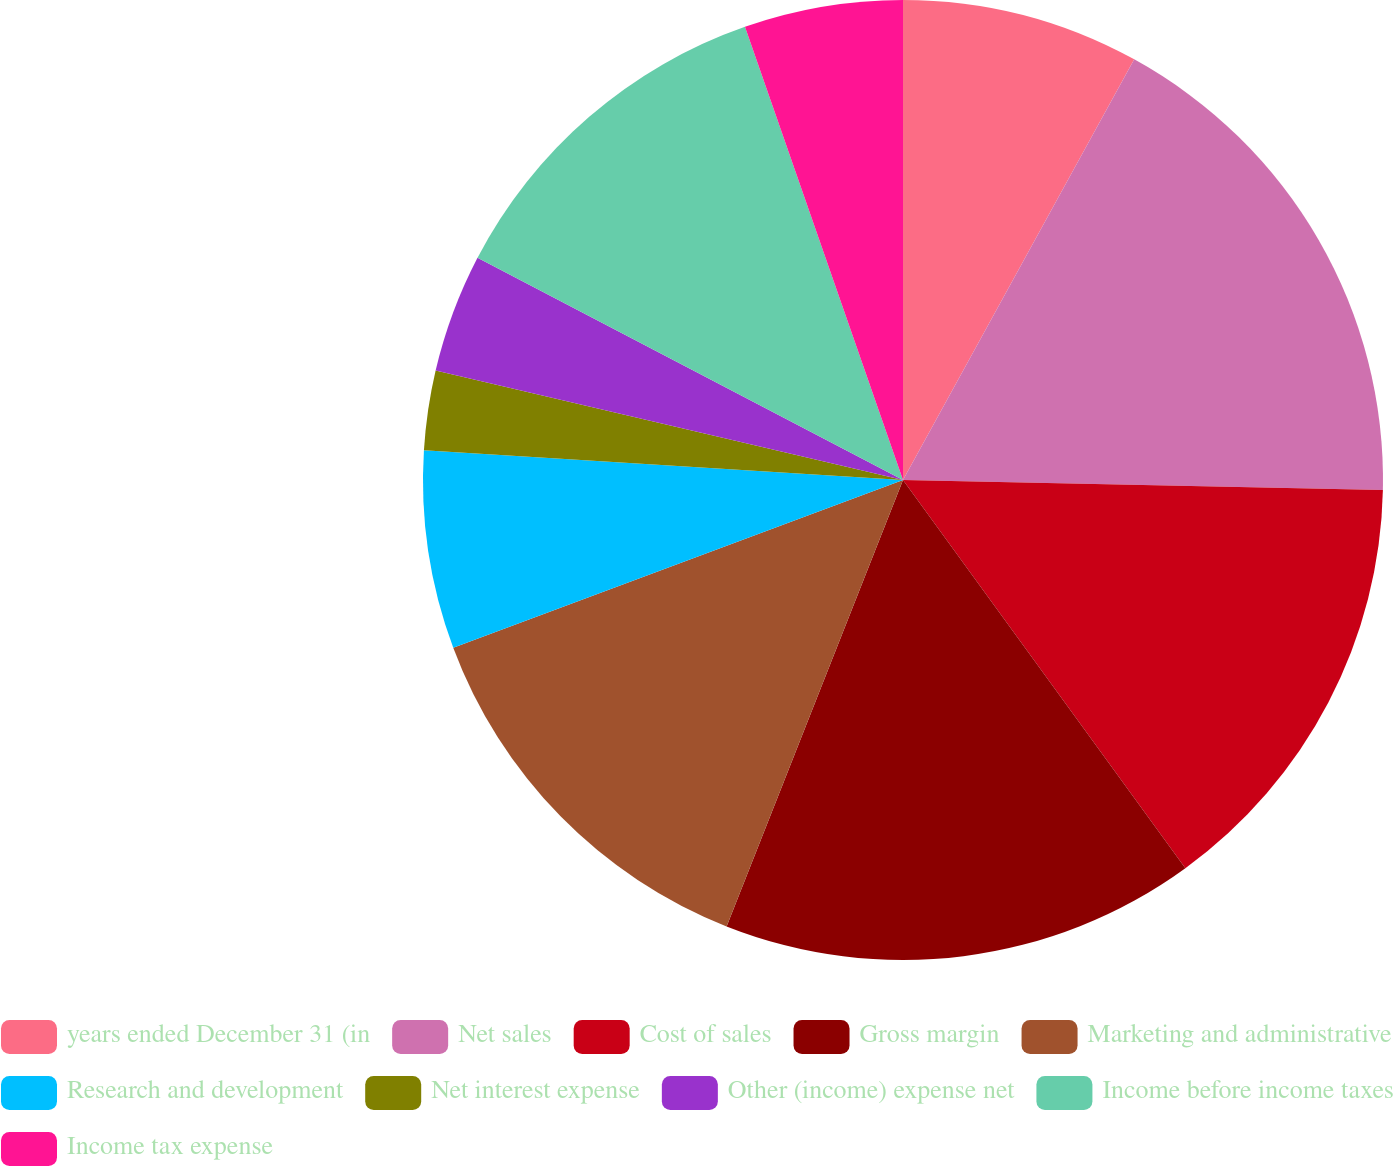<chart> <loc_0><loc_0><loc_500><loc_500><pie_chart><fcel>years ended December 31 (in<fcel>Net sales<fcel>Cost of sales<fcel>Gross margin<fcel>Marketing and administrative<fcel>Research and development<fcel>Net interest expense<fcel>Other (income) expense net<fcel>Income before income taxes<fcel>Income tax expense<nl><fcel>8.0%<fcel>17.33%<fcel>14.66%<fcel>16.0%<fcel>13.33%<fcel>6.67%<fcel>2.67%<fcel>4.0%<fcel>12.0%<fcel>5.34%<nl></chart> 